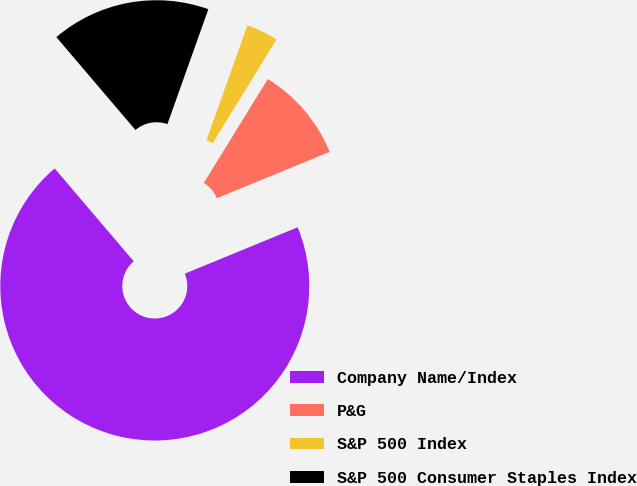Convert chart to OTSL. <chart><loc_0><loc_0><loc_500><loc_500><pie_chart><fcel>Company Name/Index<fcel>P&G<fcel>S&P 500 Index<fcel>S&P 500 Consumer Staples Index<nl><fcel>69.98%<fcel>10.01%<fcel>3.34%<fcel>16.67%<nl></chart> 